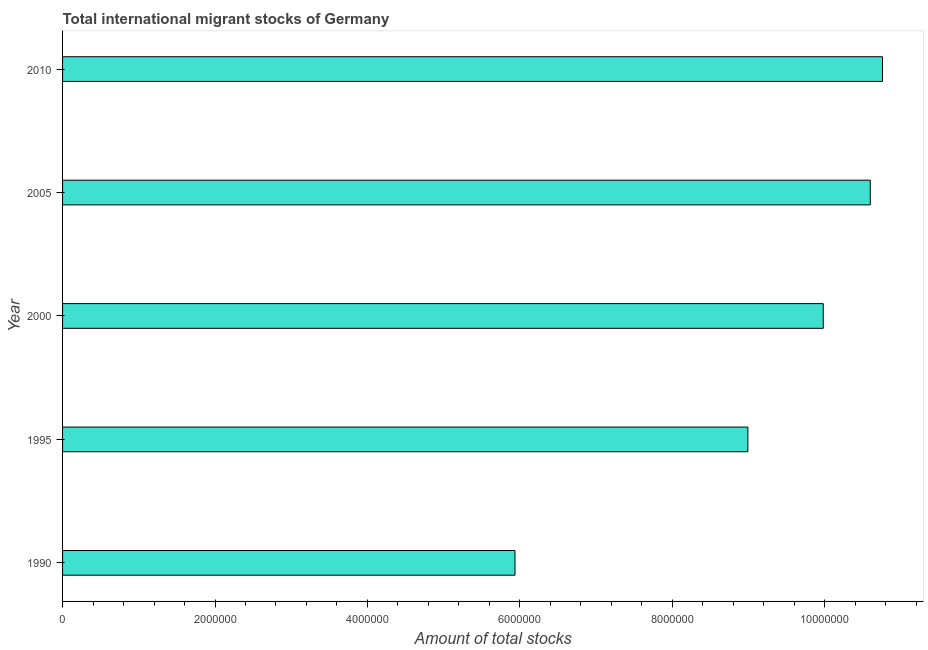Does the graph contain any zero values?
Your answer should be very brief. No. Does the graph contain grids?
Your answer should be compact. No. What is the title of the graph?
Ensure brevity in your answer.  Total international migrant stocks of Germany. What is the label or title of the X-axis?
Your response must be concise. Amount of total stocks. What is the total number of international migrant stock in 1990?
Keep it short and to the point. 5.94e+06. Across all years, what is the maximum total number of international migrant stock?
Make the answer very short. 1.08e+07. Across all years, what is the minimum total number of international migrant stock?
Keep it short and to the point. 5.94e+06. In which year was the total number of international migrant stock minimum?
Your answer should be compact. 1990. What is the sum of the total number of international migrant stock?
Make the answer very short. 4.63e+07. What is the difference between the total number of international migrant stock in 1990 and 1995?
Give a very brief answer. -3.06e+06. What is the average total number of international migrant stock per year?
Your answer should be compact. 9.25e+06. What is the median total number of international migrant stock?
Your response must be concise. 9.98e+06. In how many years, is the total number of international migrant stock greater than 10400000 ?
Keep it short and to the point. 2. Do a majority of the years between 1995 and 2005 (inclusive) have total number of international migrant stock greater than 2000000 ?
Provide a short and direct response. Yes. What is the ratio of the total number of international migrant stock in 1995 to that in 2010?
Give a very brief answer. 0.84. Is the total number of international migrant stock in 2000 less than that in 2005?
Offer a very short reply. Yes. What is the difference between the highest and the second highest total number of international migrant stock?
Ensure brevity in your answer.  1.60e+05. Is the sum of the total number of international migrant stock in 1990 and 2010 greater than the maximum total number of international migrant stock across all years?
Provide a short and direct response. Yes. What is the difference between the highest and the lowest total number of international migrant stock?
Provide a succinct answer. 4.82e+06. In how many years, is the total number of international migrant stock greater than the average total number of international migrant stock taken over all years?
Provide a succinct answer. 3. What is the difference between two consecutive major ticks on the X-axis?
Ensure brevity in your answer.  2.00e+06. Are the values on the major ticks of X-axis written in scientific E-notation?
Give a very brief answer. No. What is the Amount of total stocks of 1990?
Ensure brevity in your answer.  5.94e+06. What is the Amount of total stocks in 1995?
Offer a terse response. 8.99e+06. What is the Amount of total stocks in 2000?
Make the answer very short. 9.98e+06. What is the Amount of total stocks in 2005?
Ensure brevity in your answer.  1.06e+07. What is the Amount of total stocks of 2010?
Your response must be concise. 1.08e+07. What is the difference between the Amount of total stocks in 1990 and 1995?
Offer a terse response. -3.06e+06. What is the difference between the Amount of total stocks in 1990 and 2000?
Your answer should be very brief. -4.04e+06. What is the difference between the Amount of total stocks in 1990 and 2005?
Your answer should be very brief. -4.66e+06. What is the difference between the Amount of total stocks in 1990 and 2010?
Make the answer very short. -4.82e+06. What is the difference between the Amount of total stocks in 1995 and 2000?
Provide a succinct answer. -9.89e+05. What is the difference between the Amount of total stocks in 1995 and 2005?
Provide a short and direct response. -1.61e+06. What is the difference between the Amount of total stocks in 1995 and 2010?
Your response must be concise. -1.77e+06. What is the difference between the Amount of total stocks in 2000 and 2005?
Ensure brevity in your answer.  -6.17e+05. What is the difference between the Amount of total stocks in 2000 and 2010?
Give a very brief answer. -7.77e+05. What is the difference between the Amount of total stocks in 2005 and 2010?
Offer a terse response. -1.60e+05. What is the ratio of the Amount of total stocks in 1990 to that in 1995?
Provide a succinct answer. 0.66. What is the ratio of the Amount of total stocks in 1990 to that in 2000?
Provide a short and direct response. 0.59. What is the ratio of the Amount of total stocks in 1990 to that in 2005?
Ensure brevity in your answer.  0.56. What is the ratio of the Amount of total stocks in 1990 to that in 2010?
Your answer should be very brief. 0.55. What is the ratio of the Amount of total stocks in 1995 to that in 2000?
Make the answer very short. 0.9. What is the ratio of the Amount of total stocks in 1995 to that in 2005?
Make the answer very short. 0.85. What is the ratio of the Amount of total stocks in 1995 to that in 2010?
Your answer should be very brief. 0.84. What is the ratio of the Amount of total stocks in 2000 to that in 2005?
Keep it short and to the point. 0.94. What is the ratio of the Amount of total stocks in 2000 to that in 2010?
Your answer should be compact. 0.93. 